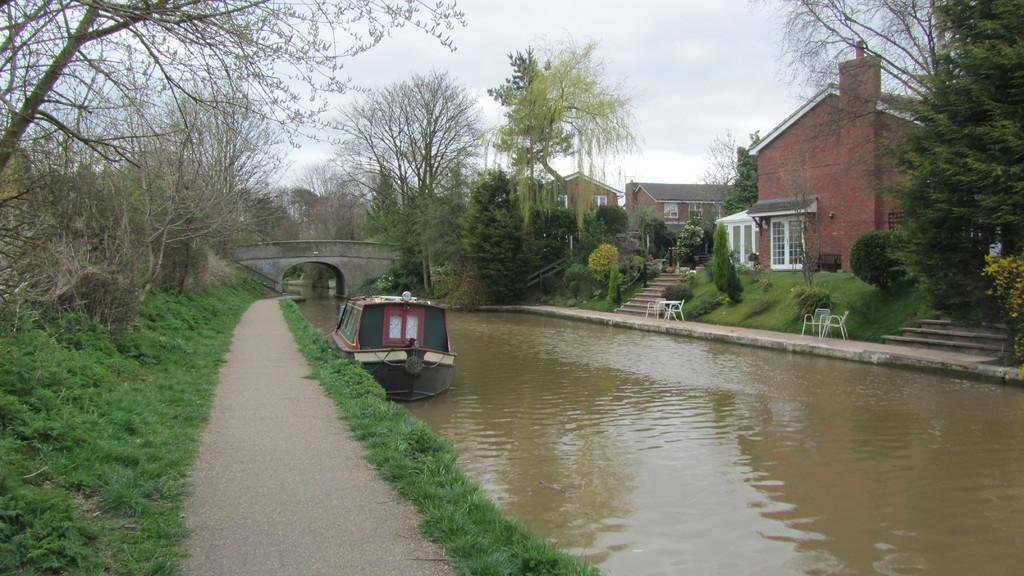What type of water body is present in the image? There is a river in the image. What is on the river in the image? There is a boat on the water in the image. What structure is visible in the image? There is a bridge in the image. What type of vegetation can be seen in the image? There are plants and trees in the image. What type of buildings are present in the image? There are homes in the image. What is visible at the top of the image? The sky is visible at the top of the image. How many porters are carrying luggage in the image? There are no porters carrying luggage in the image. What type of twig is being used as a walking stick by the crowd in the image? There is no crowd or twig present in the image. 